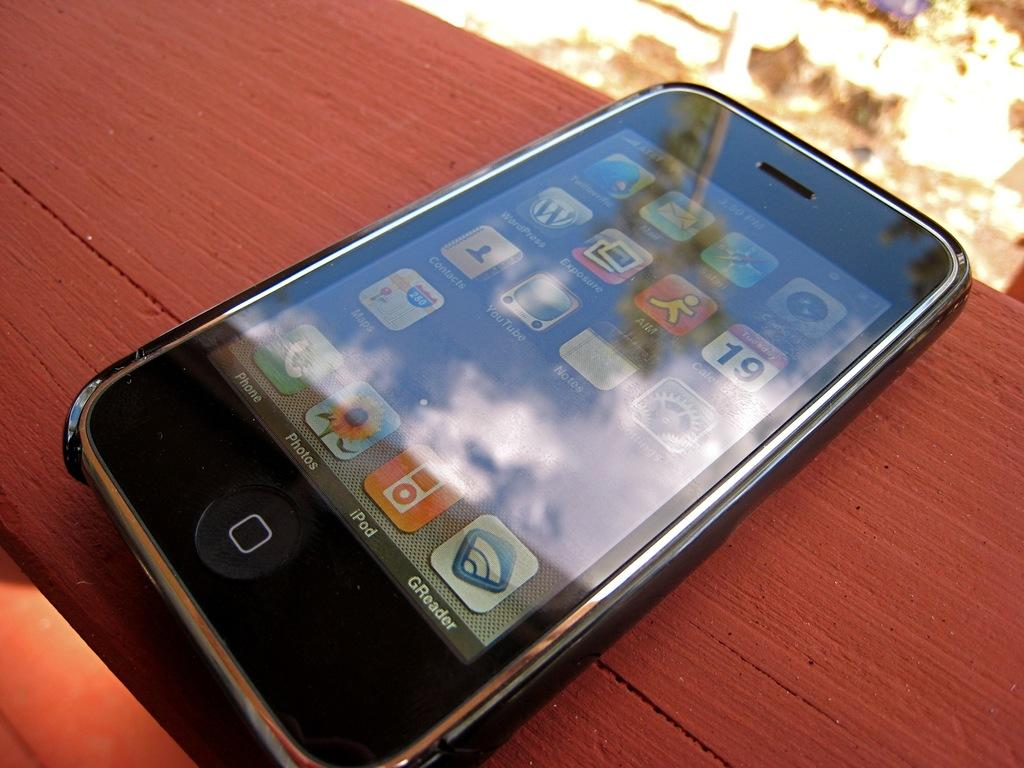Provide a one-sentence caption for the provided image. An Iphone sitting on a wood panel of a desk. 